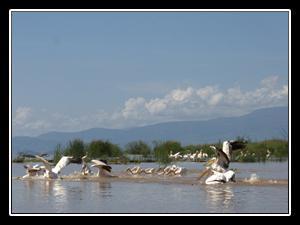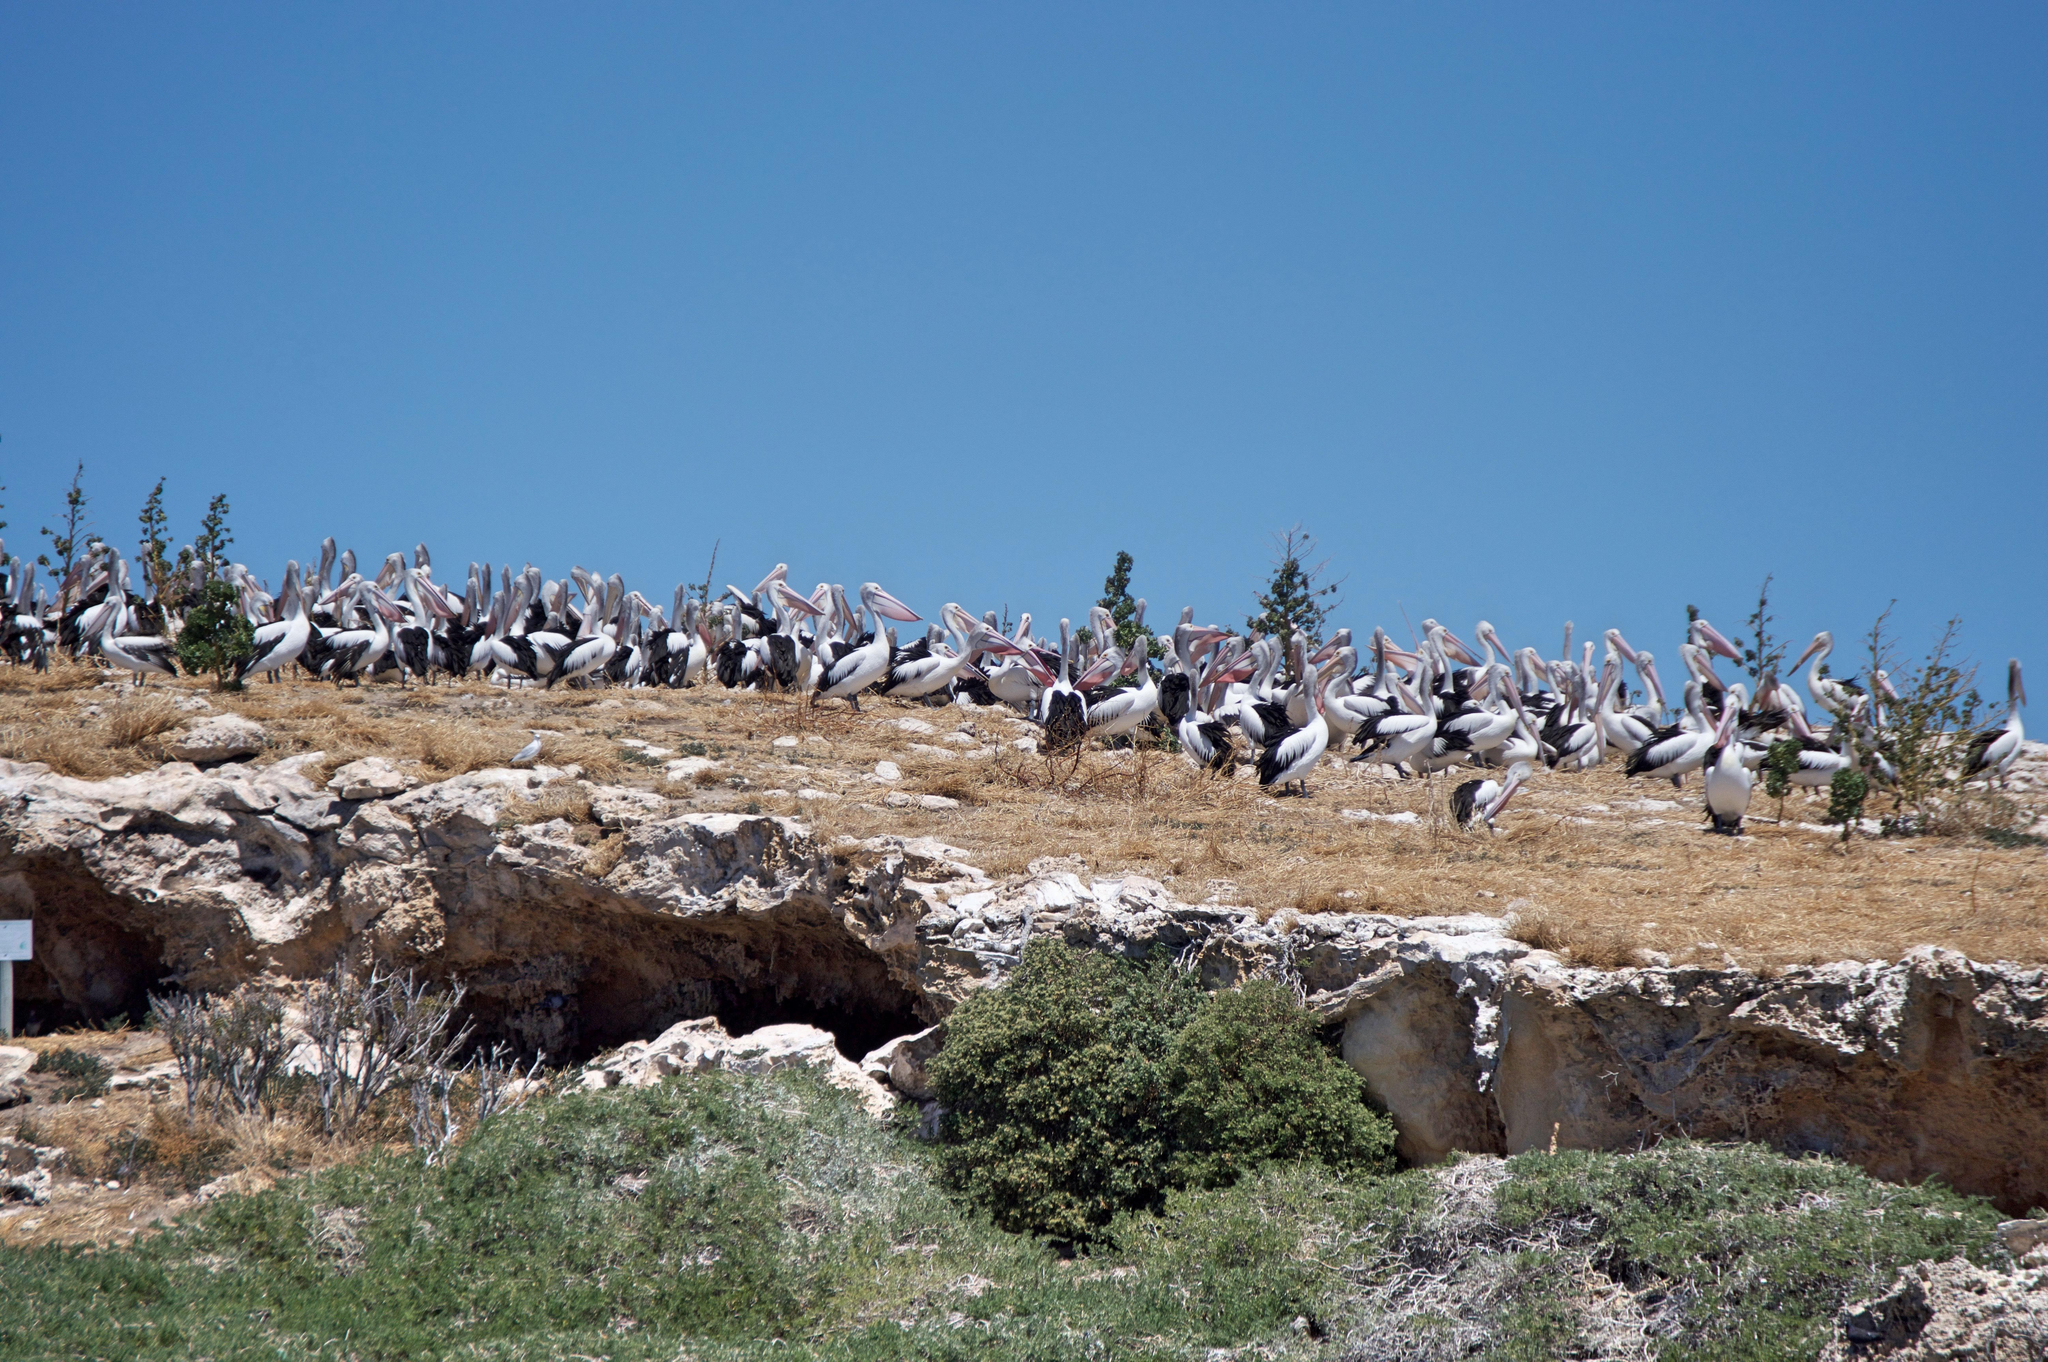The first image is the image on the left, the second image is the image on the right. Assess this claim about the two images: "Left image shows a pelican perched on a structure in the foreground.". Correct or not? Answer yes or no. No. The first image is the image on the left, the second image is the image on the right. Given the left and right images, does the statement "At least two birds are flying." hold true? Answer yes or no. No. 